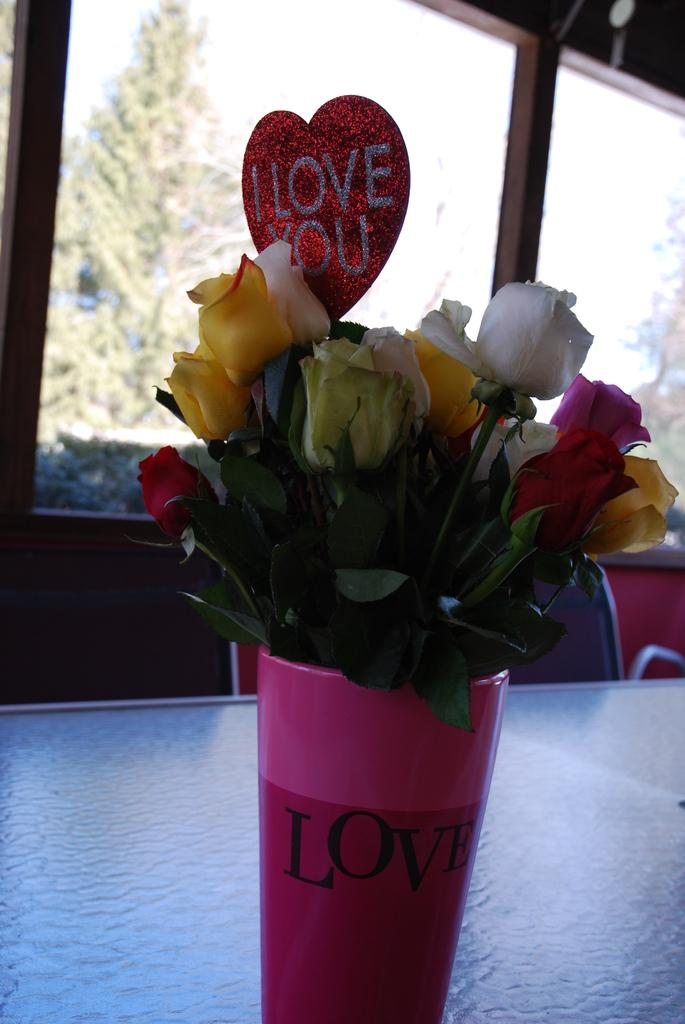What is on the table in the image? There is a flower vase on a table in the image. What type of furniture is present in the image? There are chairs in the image. What can be seen through the window in the image? Trees are visible through the window in the image. What type of vest is hanging on the window in the image? There is no vest present in the image; it only features a flower vase on a table, chairs, a window, and trees visible through the window. 